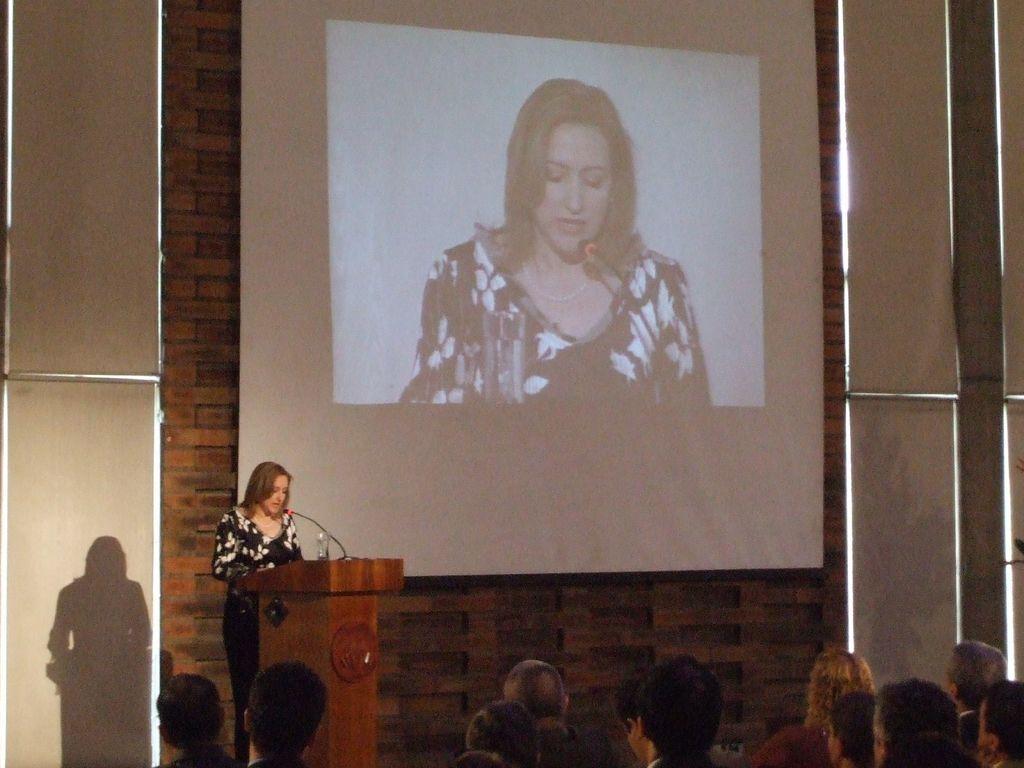How would you summarize this image in a sentence or two? This picture is clicked inside the hall. In the foreground we can see the group of persons. On the left there is a woman wearing black color floral t-shirt and standing behind the wooden podium and we can see a microphone and a glass of water. In the background we can see the wall and a projector screen on which we can see the picture of a person and the picture of a microphone and a glass of water. 